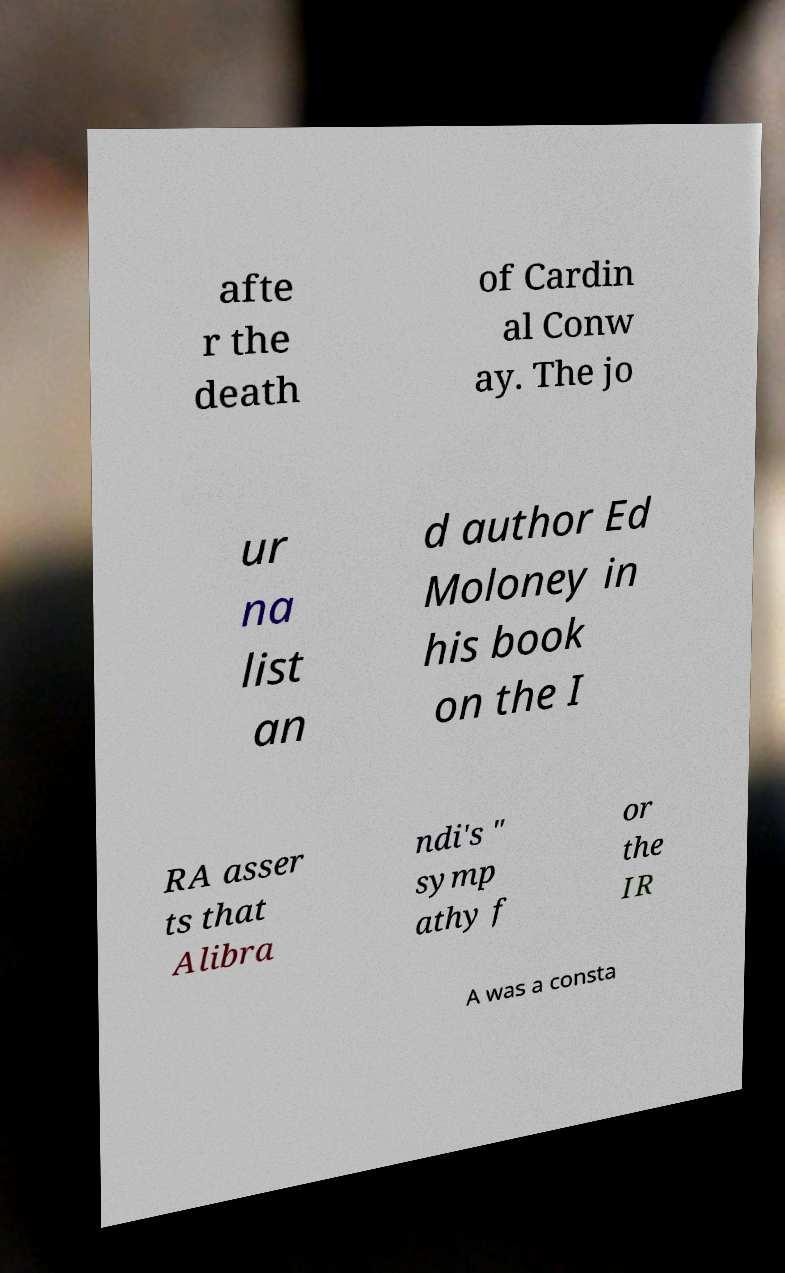There's text embedded in this image that I need extracted. Can you transcribe it verbatim? afte r the death of Cardin al Conw ay. The jo ur na list an d author Ed Moloney in his book on the I RA asser ts that Alibra ndi's " symp athy f or the IR A was a consta 